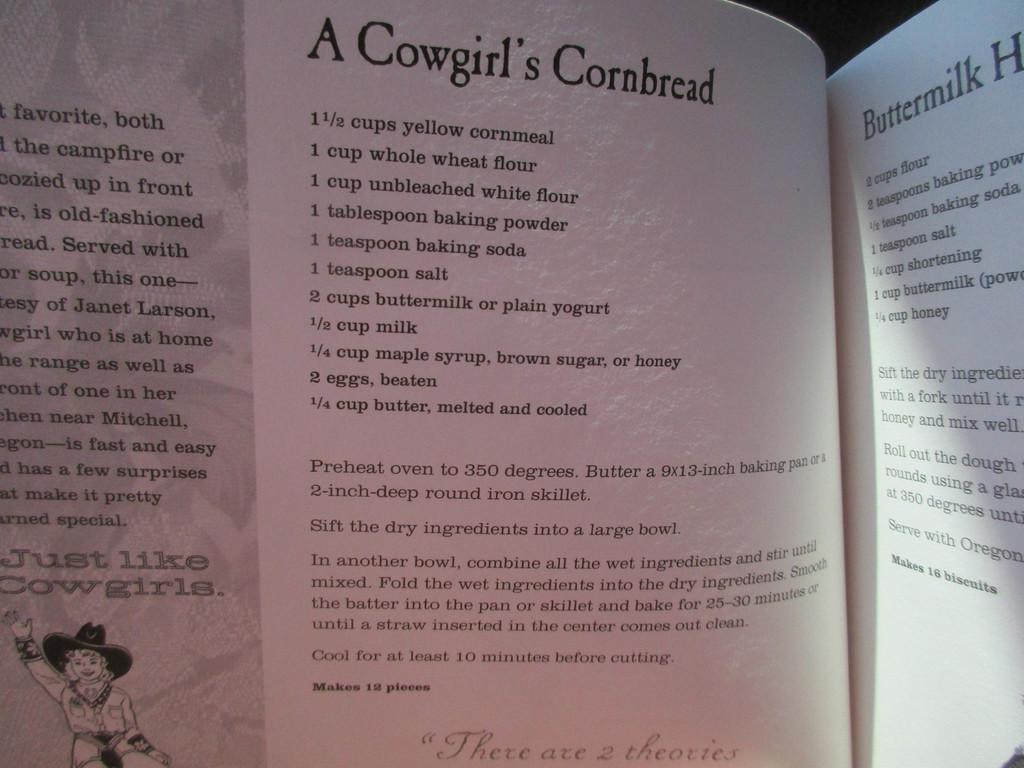In one or two sentences, can you explain what this image depicts? In this image I can see pages and on these pages I can see something is written. Here I can see depiction of a person. 